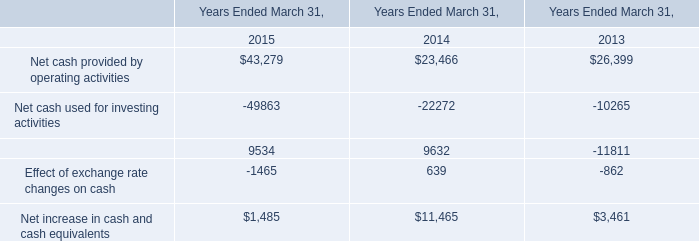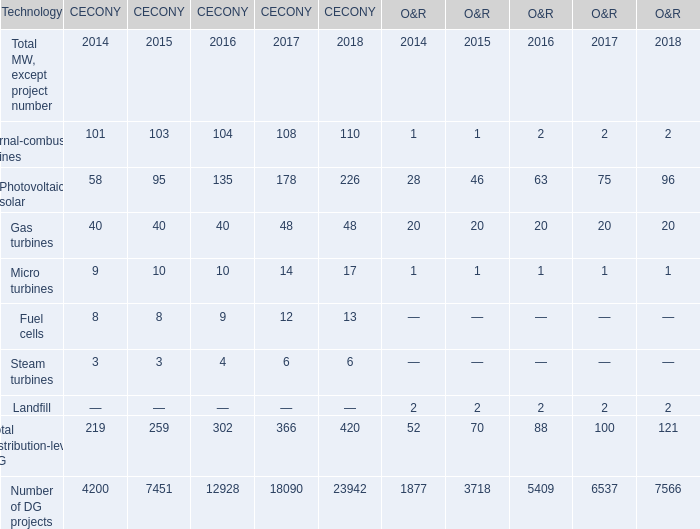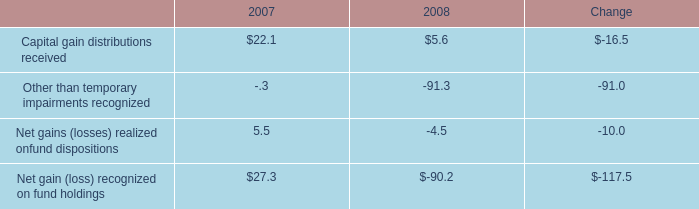What was the average value of Internal-combustion engines, Photovoltaic solar, Gas turbines in 2014 for CECONY? 
Computations: (((101 + 58) + 40) / 3)
Answer: 66.33333. 